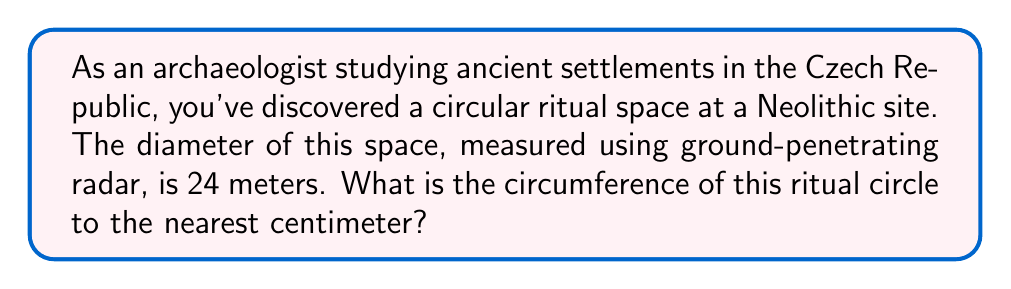Solve this math problem. To solve this problem, we need to use the formula for the circumference of a circle:

$$C = \pi d$$

Where:
$C$ = circumference
$\pi$ = pi (approximately 3.14159)
$d$ = diameter

We are given the diameter of 24 meters. Let's substitute this into our formula:

$$C = \pi \cdot 24$$

Now, let's calculate:

$$C = 3.14159 \cdot 24 = 75.39816$$

Since we need to round to the nearest centimeter, we'll round this to two decimal places:

$$C \approx 75.40 \text{ meters}$$

[asy]
import geometry;

size(200);
pair center = (0,0);
real radius = 5;
draw(circle(center, radius), red);
draw((-radius,0)--(radius,0), dashed);
label("24 m", (0,-5.5), S);
label("Ritual Space", (0,0), N);
[/asy]
Answer: The circumference of the ritual circle is approximately 75.40 meters. 